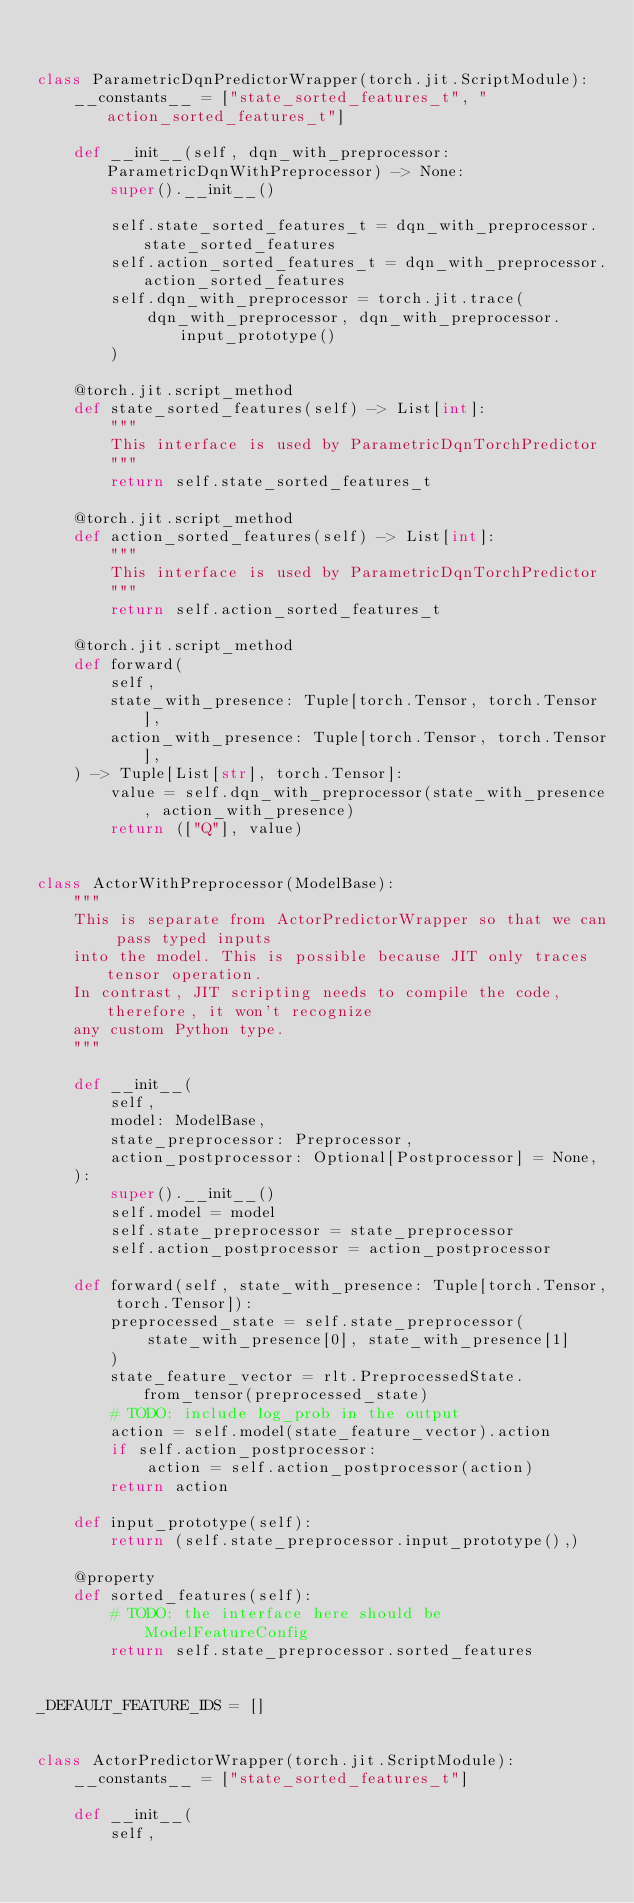<code> <loc_0><loc_0><loc_500><loc_500><_Python_>

class ParametricDqnPredictorWrapper(torch.jit.ScriptModule):
    __constants__ = ["state_sorted_features_t", "action_sorted_features_t"]

    def __init__(self, dqn_with_preprocessor: ParametricDqnWithPreprocessor) -> None:
        super().__init__()

        self.state_sorted_features_t = dqn_with_preprocessor.state_sorted_features
        self.action_sorted_features_t = dqn_with_preprocessor.action_sorted_features
        self.dqn_with_preprocessor = torch.jit.trace(
            dqn_with_preprocessor, dqn_with_preprocessor.input_prototype()
        )

    @torch.jit.script_method
    def state_sorted_features(self) -> List[int]:
        """
        This interface is used by ParametricDqnTorchPredictor
        """
        return self.state_sorted_features_t

    @torch.jit.script_method
    def action_sorted_features(self) -> List[int]:
        """
        This interface is used by ParametricDqnTorchPredictor
        """
        return self.action_sorted_features_t

    @torch.jit.script_method
    def forward(
        self,
        state_with_presence: Tuple[torch.Tensor, torch.Tensor],
        action_with_presence: Tuple[torch.Tensor, torch.Tensor],
    ) -> Tuple[List[str], torch.Tensor]:
        value = self.dqn_with_preprocessor(state_with_presence, action_with_presence)
        return (["Q"], value)


class ActorWithPreprocessor(ModelBase):
    """
    This is separate from ActorPredictorWrapper so that we can pass typed inputs
    into the model. This is possible because JIT only traces tensor operation.
    In contrast, JIT scripting needs to compile the code, therefore, it won't recognize
    any custom Python type.
    """

    def __init__(
        self,
        model: ModelBase,
        state_preprocessor: Preprocessor,
        action_postprocessor: Optional[Postprocessor] = None,
    ):
        super().__init__()
        self.model = model
        self.state_preprocessor = state_preprocessor
        self.action_postprocessor = action_postprocessor

    def forward(self, state_with_presence: Tuple[torch.Tensor, torch.Tensor]):
        preprocessed_state = self.state_preprocessor(
            state_with_presence[0], state_with_presence[1]
        )
        state_feature_vector = rlt.PreprocessedState.from_tensor(preprocessed_state)
        # TODO: include log_prob in the output
        action = self.model(state_feature_vector).action
        if self.action_postprocessor:
            action = self.action_postprocessor(action)
        return action

    def input_prototype(self):
        return (self.state_preprocessor.input_prototype(),)

    @property
    def sorted_features(self):
        # TODO: the interface here should be ModelFeatureConfig
        return self.state_preprocessor.sorted_features


_DEFAULT_FEATURE_IDS = []


class ActorPredictorWrapper(torch.jit.ScriptModule):
    __constants__ = ["state_sorted_features_t"]

    def __init__(
        self,</code> 